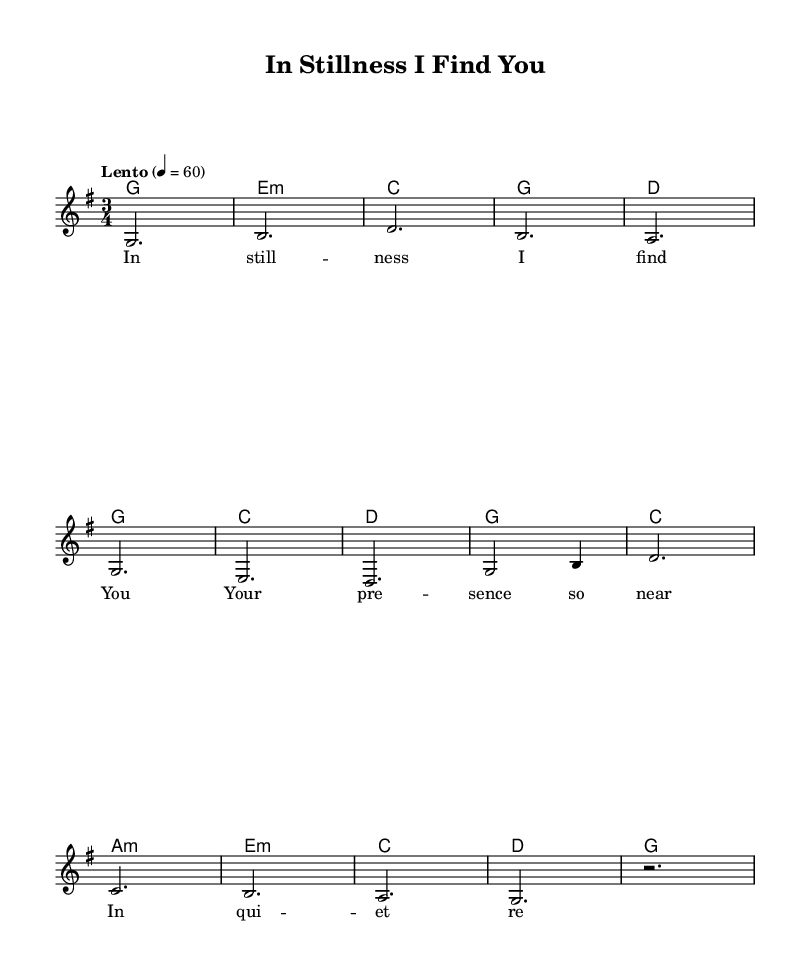What is the key signature of this music? The key signature is indicated by the presence of an F sharp in the musical staff, which means the piece is in G major, characterized by one sharp.
Answer: G major What is the time signature of this piece? The time signature is shown at the beginning of the staff with two numbers stacked vertically; "3" on top of "4" indicates that there are three beats per measure, with the quarter note getting the beat.
Answer: 3/4 What is the tempo marking given in the music? The tempo marking is indicated in the score as "Lento," which typically denotes a slow pace, and the metronome mark specifies 60 beats per minute.
Answer: Lento How many measures are in the melody section? By counting the individual groupings of notes and bar lines in the melody part, we find there are eight measures total.
Answer: 8 Which chord is played in the second measure? The chord symbol written in the second measure corresponds to E minor, which can be inferred from the symbol presented above the staff.
Answer: E minor What is the last note of the melody section? By looking at the final note in the melody part, we see that it corresponds to a rest, signifying silence at the end of the musical phrase.
Answer: Rest 